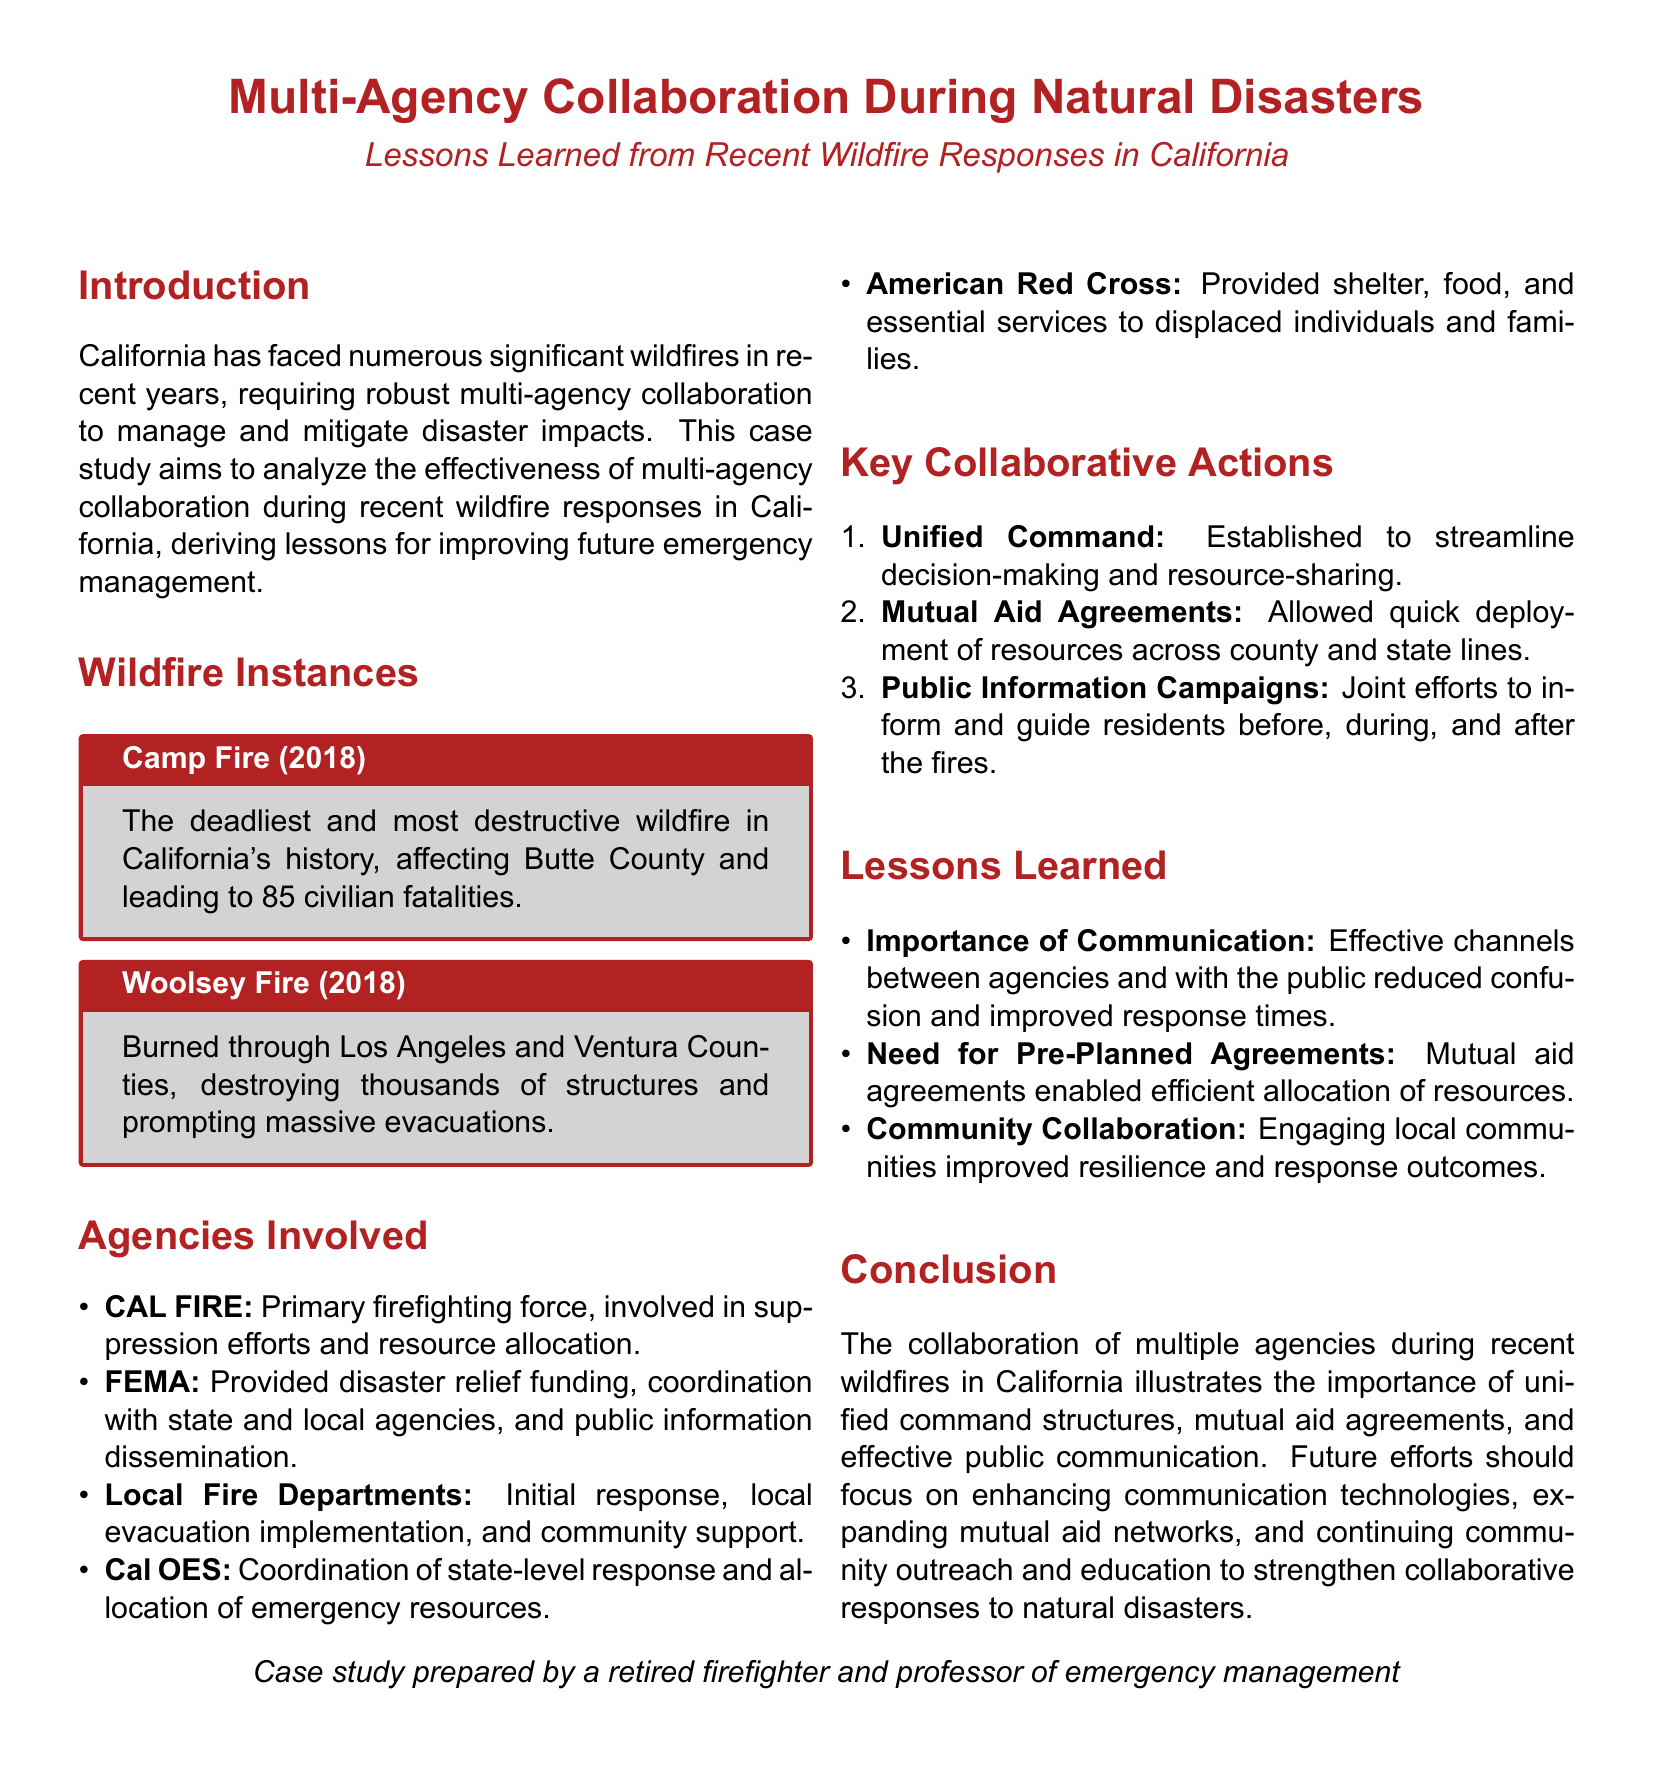What was the deadliest wildfire in California's history? The Camp Fire, as stated in the document, is noted as the deadliest and most destructive wildfire in California's history.
Answer: Camp Fire How many fatalities were caused by the Camp Fire? The document specifies that the Camp Fire led to 85 civilian fatalities.
Answer: 85 What agency is recognized as the primary firefighting force? The document lists CAL FIRE as the primary firefighting force involved in suppression efforts.
Answer: CAL FIRE What was a key collaborative action taken during the wildfire responses? The document highlights "Unified Command" as a significant collaborative action to streamline decision-making.
Answer: Unified Command Which agency provided shelter and essential services to displaced individuals? The American Red Cross is identified in the document as providing shelter, food, and essential services.
Answer: American Red Cross What lesson emphasized the need for agreements prior to disasters? The document discusses the importance of pre-planned mutual aid agreements for efficient resource allocation.
Answer: Mutual Aid Agreements What is one reason community collaboration improved responses? Engaging local communities is highlighted in the document as a way to improve resilience and response outcomes.
Answer: Community Collaboration What year did the Woolsey Fire occur? The document indicates that the Woolsey Fire occurred in 2018.
Answer: 2018 What does FEMA provide during wildfire responses, according to the document? FEMA is noted for providing disaster relief funding and coordination with various agencies.
Answer: Disaster Relief Funding 